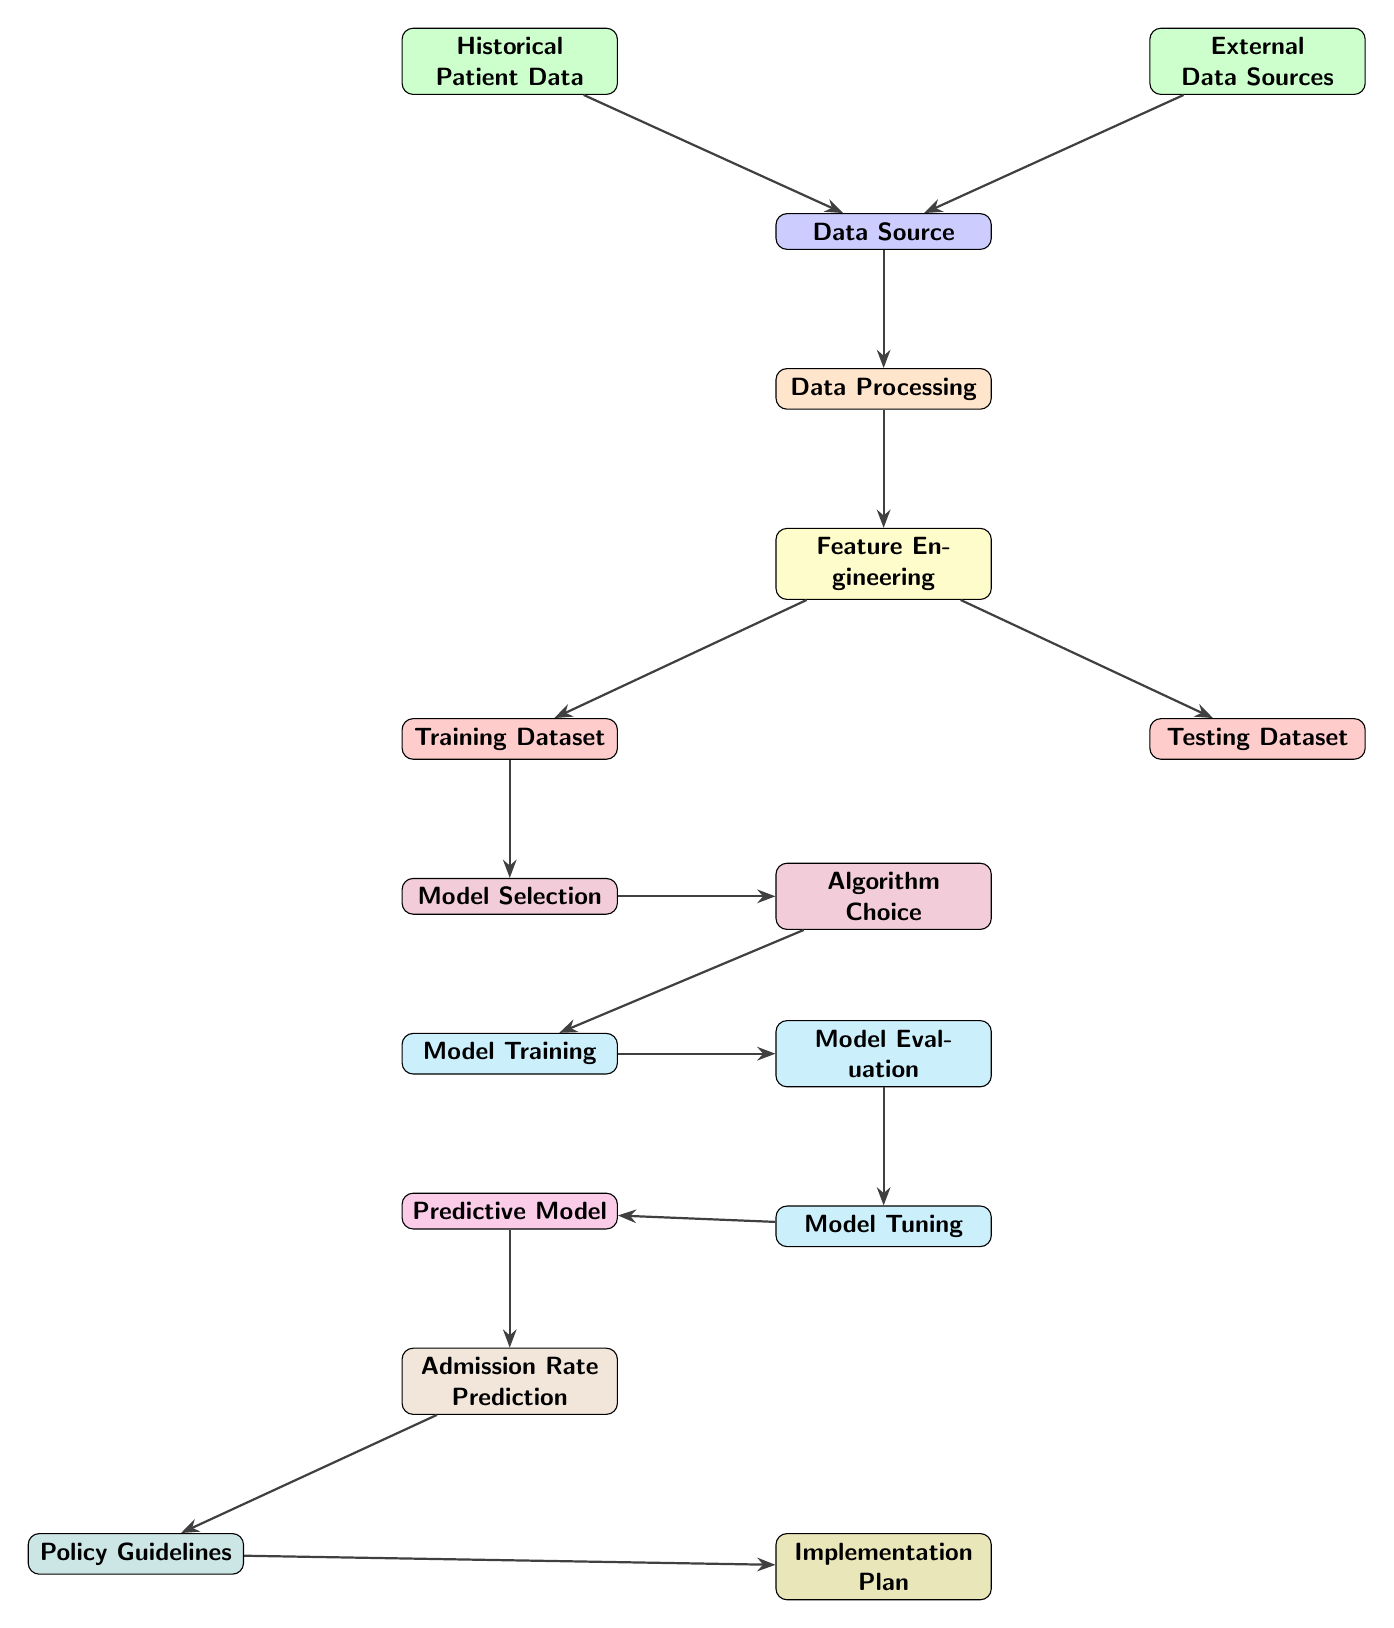What is the input for the data processing node? The input for the data processing node is the data source, which is fed from the combination of historical patient data and external data sources.
Answer: Data Source How many different colored boxes are there in the diagram? The diagram contains 11 different colored boxes, each representing different steps or components in the predictive analytics process.
Answer: 11 What is the relationship between model training and model evaluation? The relationship is that model training is followed by model evaluation, indicating that after a model is trained, its performance must be evaluated next.
Answer: Evaluates performance What happens after model tuning? After model tuning, the process moves to optimize the model, indicating that adjustments made during tuning are aimed at enhancing the model's performance further.
Answer: Optimize Model What is produced by the predictive model? The predictive model generates admission rate predictions, indicating that the primary output of this model is the forecasted admission rates based on input data.
Answer: Admission Rate Prediction How does the specification of algorithms relate to model selection? The algorithm choice is a direct result of model selection, indicating that choosing specific algorithms is part of the overall model selection process.
Answer: Select Approach What are the final outcomes of the predictive analytics process? The final outcomes of the predictive analytics process are policy guidelines and an implementation plan, which are generated based on the admission rate predictions.
Answer: Policy Guidelines and Implementation Plan Which data type is used alongside historical patient data? The data type used alongside historical patient data is external data sources, indicating the integration of various types of data for analysis.
Answer: External Data Sources What is the process that follows data processing? Following data processing, the next step is feature engineering, indicating the transition from basic data handling to preparing features for the modeling stage.
Answer: Feature Engineering 